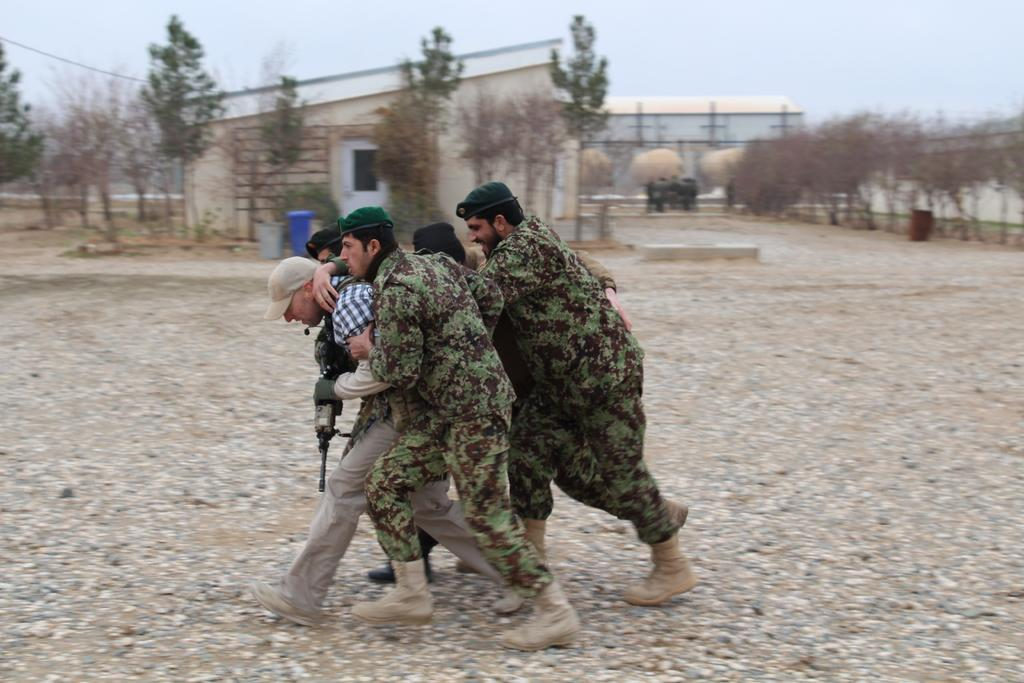What are the people in the image doing? The people in the image are walking on the surface. What can be seen in the background of the image? There are buildings, trees, and the sky visible in the background of the image. What type of amusement can be seen in the hospital in the image? There is no hospital or amusement present in the image; it features people walking and background elements such as buildings, trees, and the sky. 